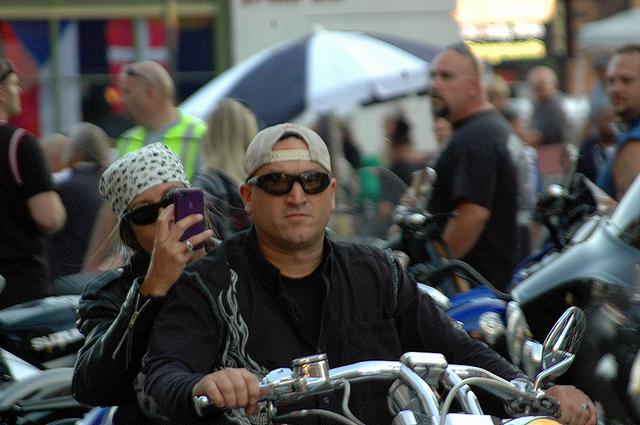Why is the woman wearing a white bandana holding a phone up?

Choices:
A) buying items
B) playing games
C) taking pictures
D) calling 911 taking pictures 